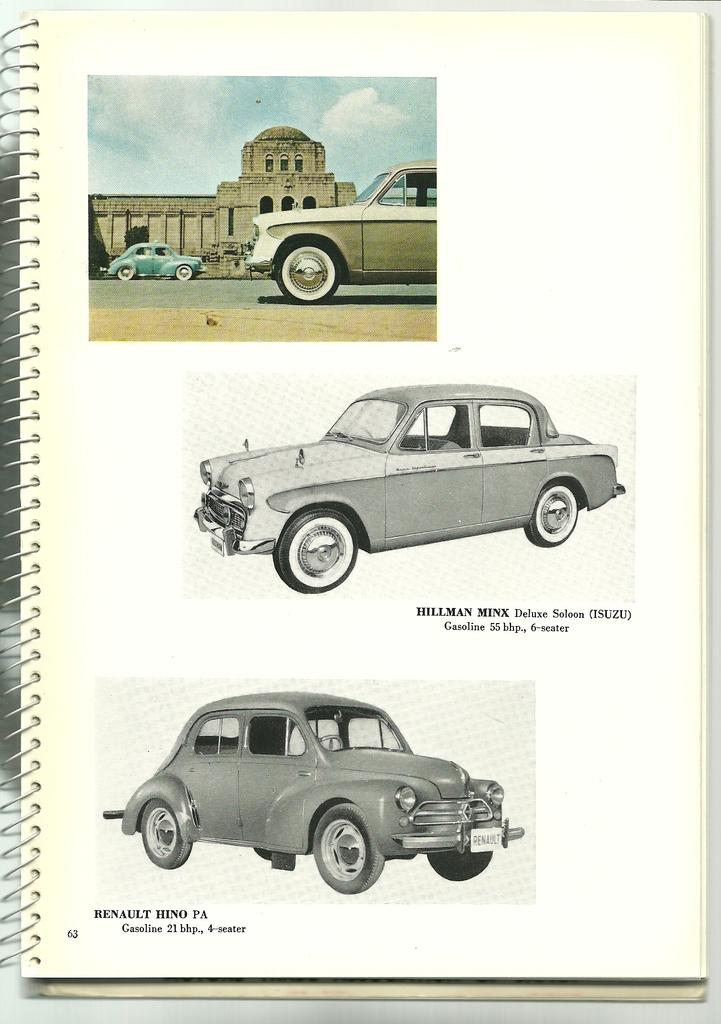What is the main subject of the images on the paper? The main subject of the images on the paper is a car. How many images of the car are present on the paper? There are three images of a car on the paper. What route does the car take in the images? The images do not depict a route or journey; they simply show three images of a car. Is the car in the images part of a book? The provided facts do not mention a book, so we cannot determine if the images are part of a book or not. 